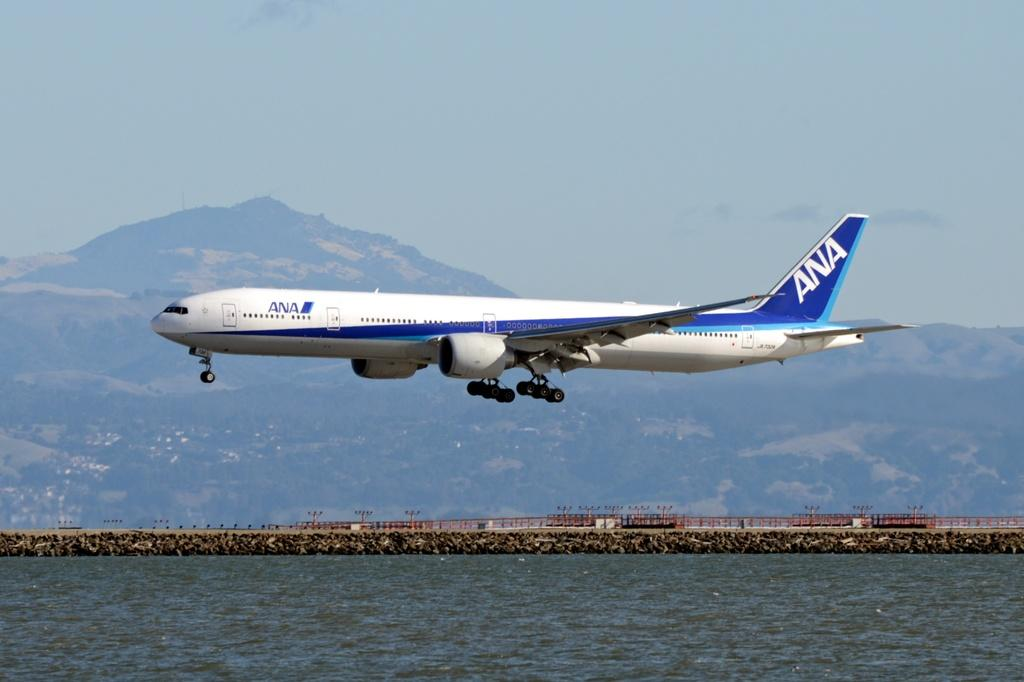<image>
Provide a brief description of the given image. An Ana aircraft flies low over a body of water. 